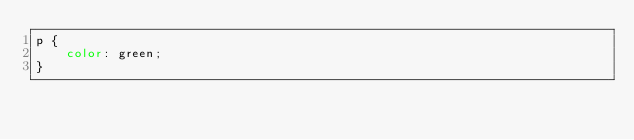<code> <loc_0><loc_0><loc_500><loc_500><_CSS_>p {
    color: green;
}</code> 